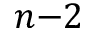Convert formula to latex. <formula><loc_0><loc_0><loc_500><loc_500>n { - } 2</formula> 